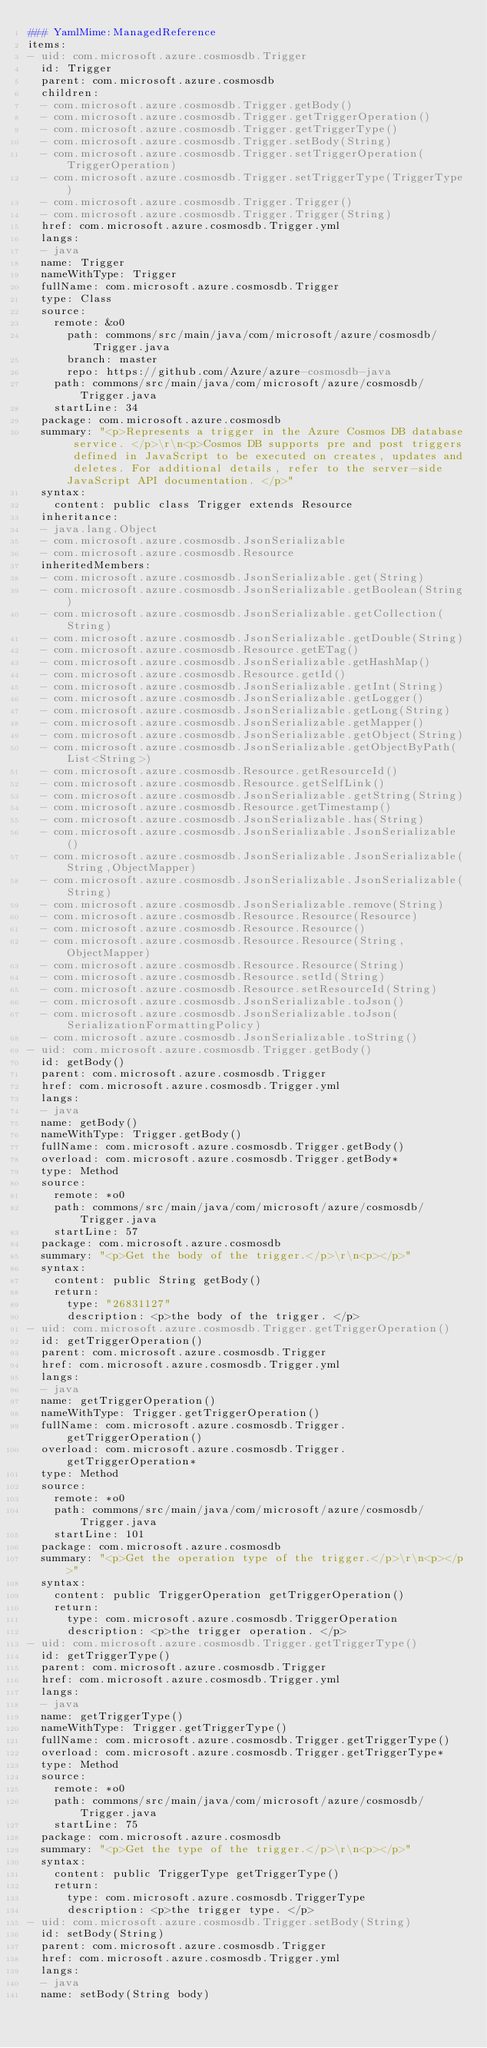Convert code to text. <code><loc_0><loc_0><loc_500><loc_500><_YAML_>### YamlMime:ManagedReference
items:
- uid: com.microsoft.azure.cosmosdb.Trigger
  id: Trigger
  parent: com.microsoft.azure.cosmosdb
  children:
  - com.microsoft.azure.cosmosdb.Trigger.getBody()
  - com.microsoft.azure.cosmosdb.Trigger.getTriggerOperation()
  - com.microsoft.azure.cosmosdb.Trigger.getTriggerType()
  - com.microsoft.azure.cosmosdb.Trigger.setBody(String)
  - com.microsoft.azure.cosmosdb.Trigger.setTriggerOperation(TriggerOperation)
  - com.microsoft.azure.cosmosdb.Trigger.setTriggerType(TriggerType)
  - com.microsoft.azure.cosmosdb.Trigger.Trigger()
  - com.microsoft.azure.cosmosdb.Trigger.Trigger(String)
  href: com.microsoft.azure.cosmosdb.Trigger.yml
  langs:
  - java
  name: Trigger
  nameWithType: Trigger
  fullName: com.microsoft.azure.cosmosdb.Trigger
  type: Class
  source:
    remote: &o0
      path: commons/src/main/java/com/microsoft/azure/cosmosdb/Trigger.java
      branch: master
      repo: https://github.com/Azure/azure-cosmosdb-java
    path: commons/src/main/java/com/microsoft/azure/cosmosdb/Trigger.java
    startLine: 34
  package: com.microsoft.azure.cosmosdb
  summary: "<p>Represents a trigger in the Azure Cosmos DB database service. </p>\r\n<p>Cosmos DB supports pre and post triggers defined in JavaScript to be executed on creates, updates and deletes. For additional details, refer to the server-side JavaScript API documentation. </p>"
  syntax:
    content: public class Trigger extends Resource
  inheritance:
  - java.lang.Object
  - com.microsoft.azure.cosmosdb.JsonSerializable
  - com.microsoft.azure.cosmosdb.Resource
  inheritedMembers:
  - com.microsoft.azure.cosmosdb.JsonSerializable.get(String)
  - com.microsoft.azure.cosmosdb.JsonSerializable.getBoolean(String)
  - com.microsoft.azure.cosmosdb.JsonSerializable.getCollection(String)
  - com.microsoft.azure.cosmosdb.JsonSerializable.getDouble(String)
  - com.microsoft.azure.cosmosdb.Resource.getETag()
  - com.microsoft.azure.cosmosdb.JsonSerializable.getHashMap()
  - com.microsoft.azure.cosmosdb.Resource.getId()
  - com.microsoft.azure.cosmosdb.JsonSerializable.getInt(String)
  - com.microsoft.azure.cosmosdb.JsonSerializable.getLogger()
  - com.microsoft.azure.cosmosdb.JsonSerializable.getLong(String)
  - com.microsoft.azure.cosmosdb.JsonSerializable.getMapper()
  - com.microsoft.azure.cosmosdb.JsonSerializable.getObject(String)
  - com.microsoft.azure.cosmosdb.JsonSerializable.getObjectByPath(List<String>)
  - com.microsoft.azure.cosmosdb.Resource.getResourceId()
  - com.microsoft.azure.cosmosdb.Resource.getSelfLink()
  - com.microsoft.azure.cosmosdb.JsonSerializable.getString(String)
  - com.microsoft.azure.cosmosdb.Resource.getTimestamp()
  - com.microsoft.azure.cosmosdb.JsonSerializable.has(String)
  - com.microsoft.azure.cosmosdb.JsonSerializable.JsonSerializable()
  - com.microsoft.azure.cosmosdb.JsonSerializable.JsonSerializable(String,ObjectMapper)
  - com.microsoft.azure.cosmosdb.JsonSerializable.JsonSerializable(String)
  - com.microsoft.azure.cosmosdb.JsonSerializable.remove(String)
  - com.microsoft.azure.cosmosdb.Resource.Resource(Resource)
  - com.microsoft.azure.cosmosdb.Resource.Resource()
  - com.microsoft.azure.cosmosdb.Resource.Resource(String,ObjectMapper)
  - com.microsoft.azure.cosmosdb.Resource.Resource(String)
  - com.microsoft.azure.cosmosdb.Resource.setId(String)
  - com.microsoft.azure.cosmosdb.Resource.setResourceId(String)
  - com.microsoft.azure.cosmosdb.JsonSerializable.toJson()
  - com.microsoft.azure.cosmosdb.JsonSerializable.toJson(SerializationFormattingPolicy)
  - com.microsoft.azure.cosmosdb.JsonSerializable.toString()
- uid: com.microsoft.azure.cosmosdb.Trigger.getBody()
  id: getBody()
  parent: com.microsoft.azure.cosmosdb.Trigger
  href: com.microsoft.azure.cosmosdb.Trigger.yml
  langs:
  - java
  name: getBody()
  nameWithType: Trigger.getBody()
  fullName: com.microsoft.azure.cosmosdb.Trigger.getBody()
  overload: com.microsoft.azure.cosmosdb.Trigger.getBody*
  type: Method
  source:
    remote: *o0
    path: commons/src/main/java/com/microsoft/azure/cosmosdb/Trigger.java
    startLine: 57
  package: com.microsoft.azure.cosmosdb
  summary: "<p>Get the body of the trigger.</p>\r\n<p></p>"
  syntax:
    content: public String getBody()
    return:
      type: "26831127"
      description: <p>the body of the trigger. </p>
- uid: com.microsoft.azure.cosmosdb.Trigger.getTriggerOperation()
  id: getTriggerOperation()
  parent: com.microsoft.azure.cosmosdb.Trigger
  href: com.microsoft.azure.cosmosdb.Trigger.yml
  langs:
  - java
  name: getTriggerOperation()
  nameWithType: Trigger.getTriggerOperation()
  fullName: com.microsoft.azure.cosmosdb.Trigger.getTriggerOperation()
  overload: com.microsoft.azure.cosmosdb.Trigger.getTriggerOperation*
  type: Method
  source:
    remote: *o0
    path: commons/src/main/java/com/microsoft/azure/cosmosdb/Trigger.java
    startLine: 101
  package: com.microsoft.azure.cosmosdb
  summary: "<p>Get the operation type of the trigger.</p>\r\n<p></p>"
  syntax:
    content: public TriggerOperation getTriggerOperation()
    return:
      type: com.microsoft.azure.cosmosdb.TriggerOperation
      description: <p>the trigger operation. </p>
- uid: com.microsoft.azure.cosmosdb.Trigger.getTriggerType()
  id: getTriggerType()
  parent: com.microsoft.azure.cosmosdb.Trigger
  href: com.microsoft.azure.cosmosdb.Trigger.yml
  langs:
  - java
  name: getTriggerType()
  nameWithType: Trigger.getTriggerType()
  fullName: com.microsoft.azure.cosmosdb.Trigger.getTriggerType()
  overload: com.microsoft.azure.cosmosdb.Trigger.getTriggerType*
  type: Method
  source:
    remote: *o0
    path: commons/src/main/java/com/microsoft/azure/cosmosdb/Trigger.java
    startLine: 75
  package: com.microsoft.azure.cosmosdb
  summary: "<p>Get the type of the trigger.</p>\r\n<p></p>"
  syntax:
    content: public TriggerType getTriggerType()
    return:
      type: com.microsoft.azure.cosmosdb.TriggerType
      description: <p>the trigger type. </p>
- uid: com.microsoft.azure.cosmosdb.Trigger.setBody(String)
  id: setBody(String)
  parent: com.microsoft.azure.cosmosdb.Trigger
  href: com.microsoft.azure.cosmosdb.Trigger.yml
  langs:
  - java
  name: setBody(String body)</code> 